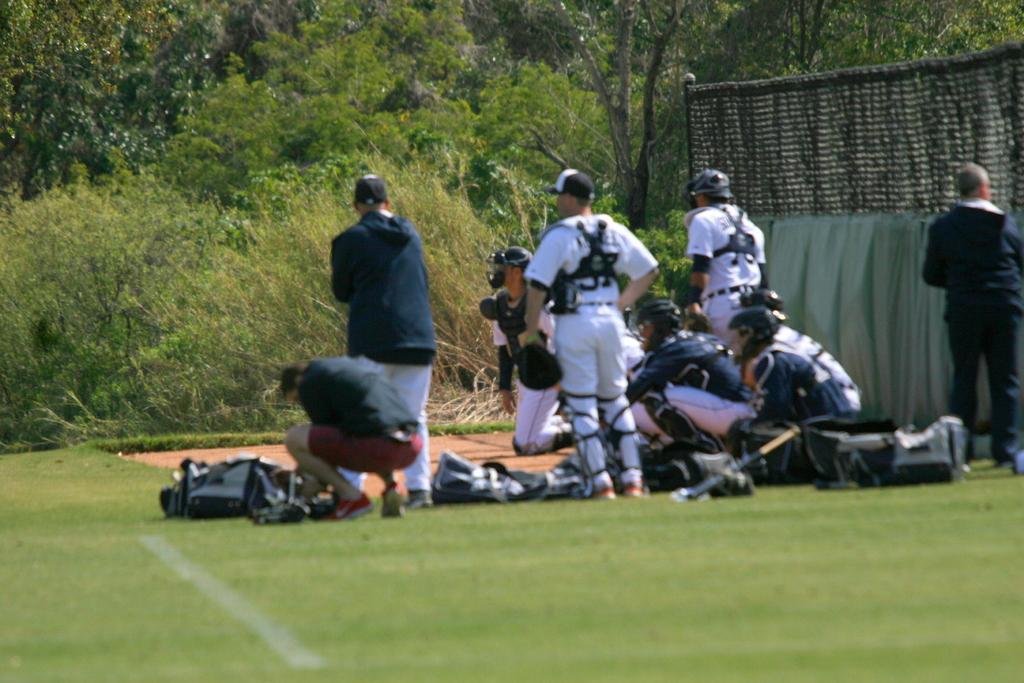Please provide a concise description of this image. In this image we can see these people are standing on the ground, here we can see bags, net and trees in the background. 